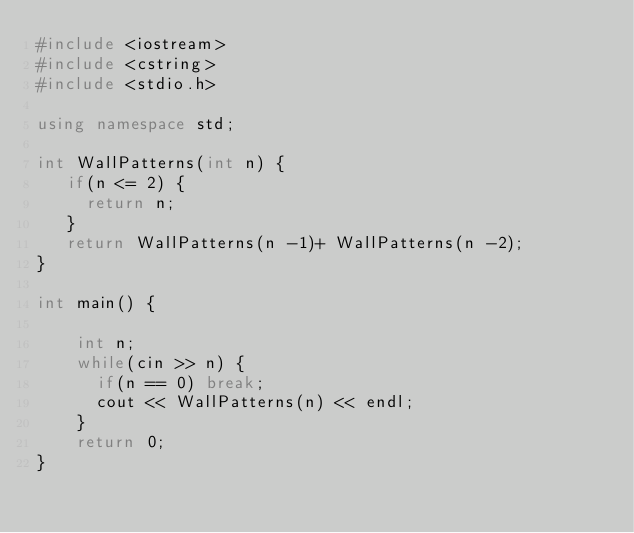<code> <loc_0><loc_0><loc_500><loc_500><_C++_>#include <iostream>
#include <cstring>
#include <stdio.h>

using namespace std;

int WallPatterns(int n) {
   if(n <= 2) {
     return n;     
   }
   return WallPatterns(n -1)+ WallPatterns(n -2);    
}

int main() {
    
    int n;
    while(cin >> n) {   
      if(n == 0) break;        
      cout << WallPatterns(n) << endl;
    } 
    return 0;
}
</code> 